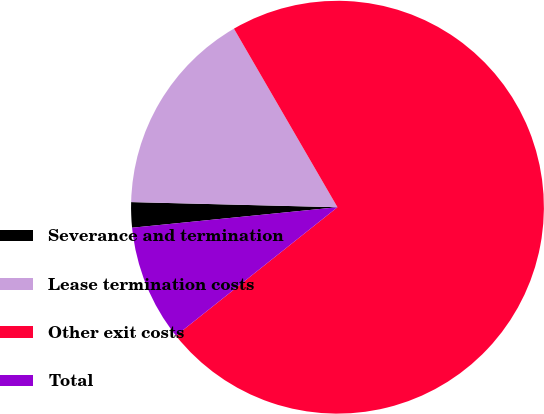Convert chart. <chart><loc_0><loc_0><loc_500><loc_500><pie_chart><fcel>Severance and termination<fcel>Lease termination costs<fcel>Other exit costs<fcel>Total<nl><fcel>1.98%<fcel>16.24%<fcel>72.67%<fcel>9.11%<nl></chart> 